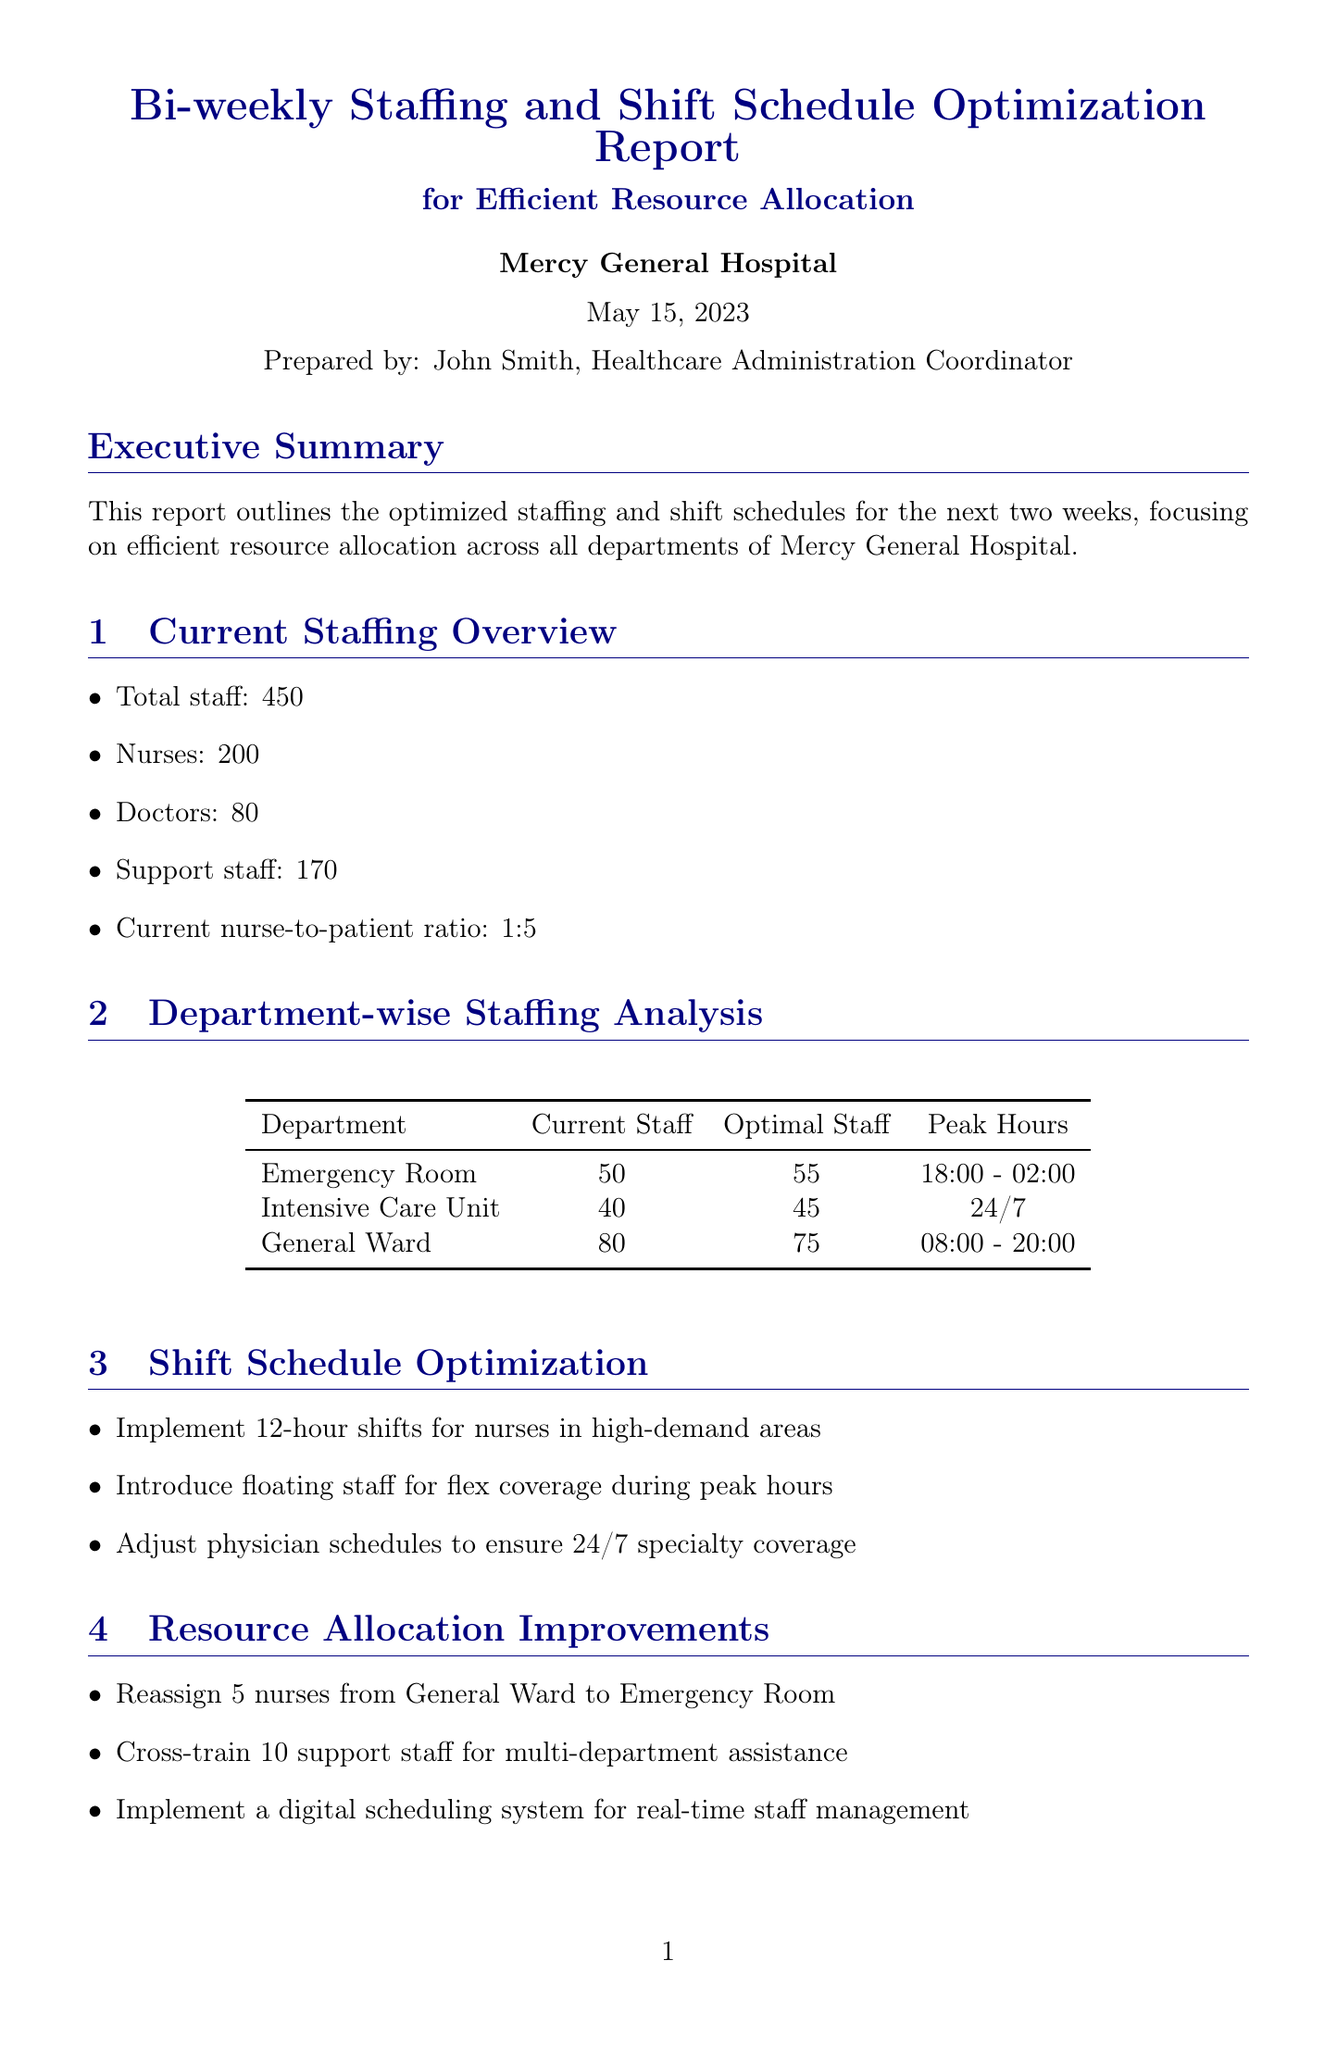What is the title of the report? The title of the report is explicitly stated at the beginning of the document.
Answer: Bi-weekly Staffing and Shift Schedule Optimization Report for Efficient Resource Allocation Who prepared the report? The prepared by section names the individual responsible for preparing the report.
Answer: John Smith What is the current nurse-to-patient ratio? The current nurse-to-patient ratio is provided in the Current Staffing Overview section.
Answer: 1:5 How many current staff are in the Intensive Care Unit? The number of current staff in the Intensive Care Unit is detailed in the Department-wise Staffing Analysis section.
Answer: 40 What are the peak hours for the Emergency Room? The peak hours for the Emergency Room are specified in the Department-wise Staffing Analysis section.
Answer: 18:00 - 02:00 What percentage is the projected overtime reduction? The projected overtime reduction is mentioned in the Cost Analysis section.
Answer: 15% What is one recommendation for resource allocation improvements? The recommendations for resource allocation improvements are listed in a specific section of the report.
Answer: Reassign 5 nurses from General Ward to Emergency Room Which technology is proposed for automated scheduling? The technology integration section lists tools for scheduling and management.
Answer: ShiftWise Pro What is the date for the full implementation of optimized schedules? The next steps section provides dates for milestones, including full implementation.
Answer: 2023-06-15 